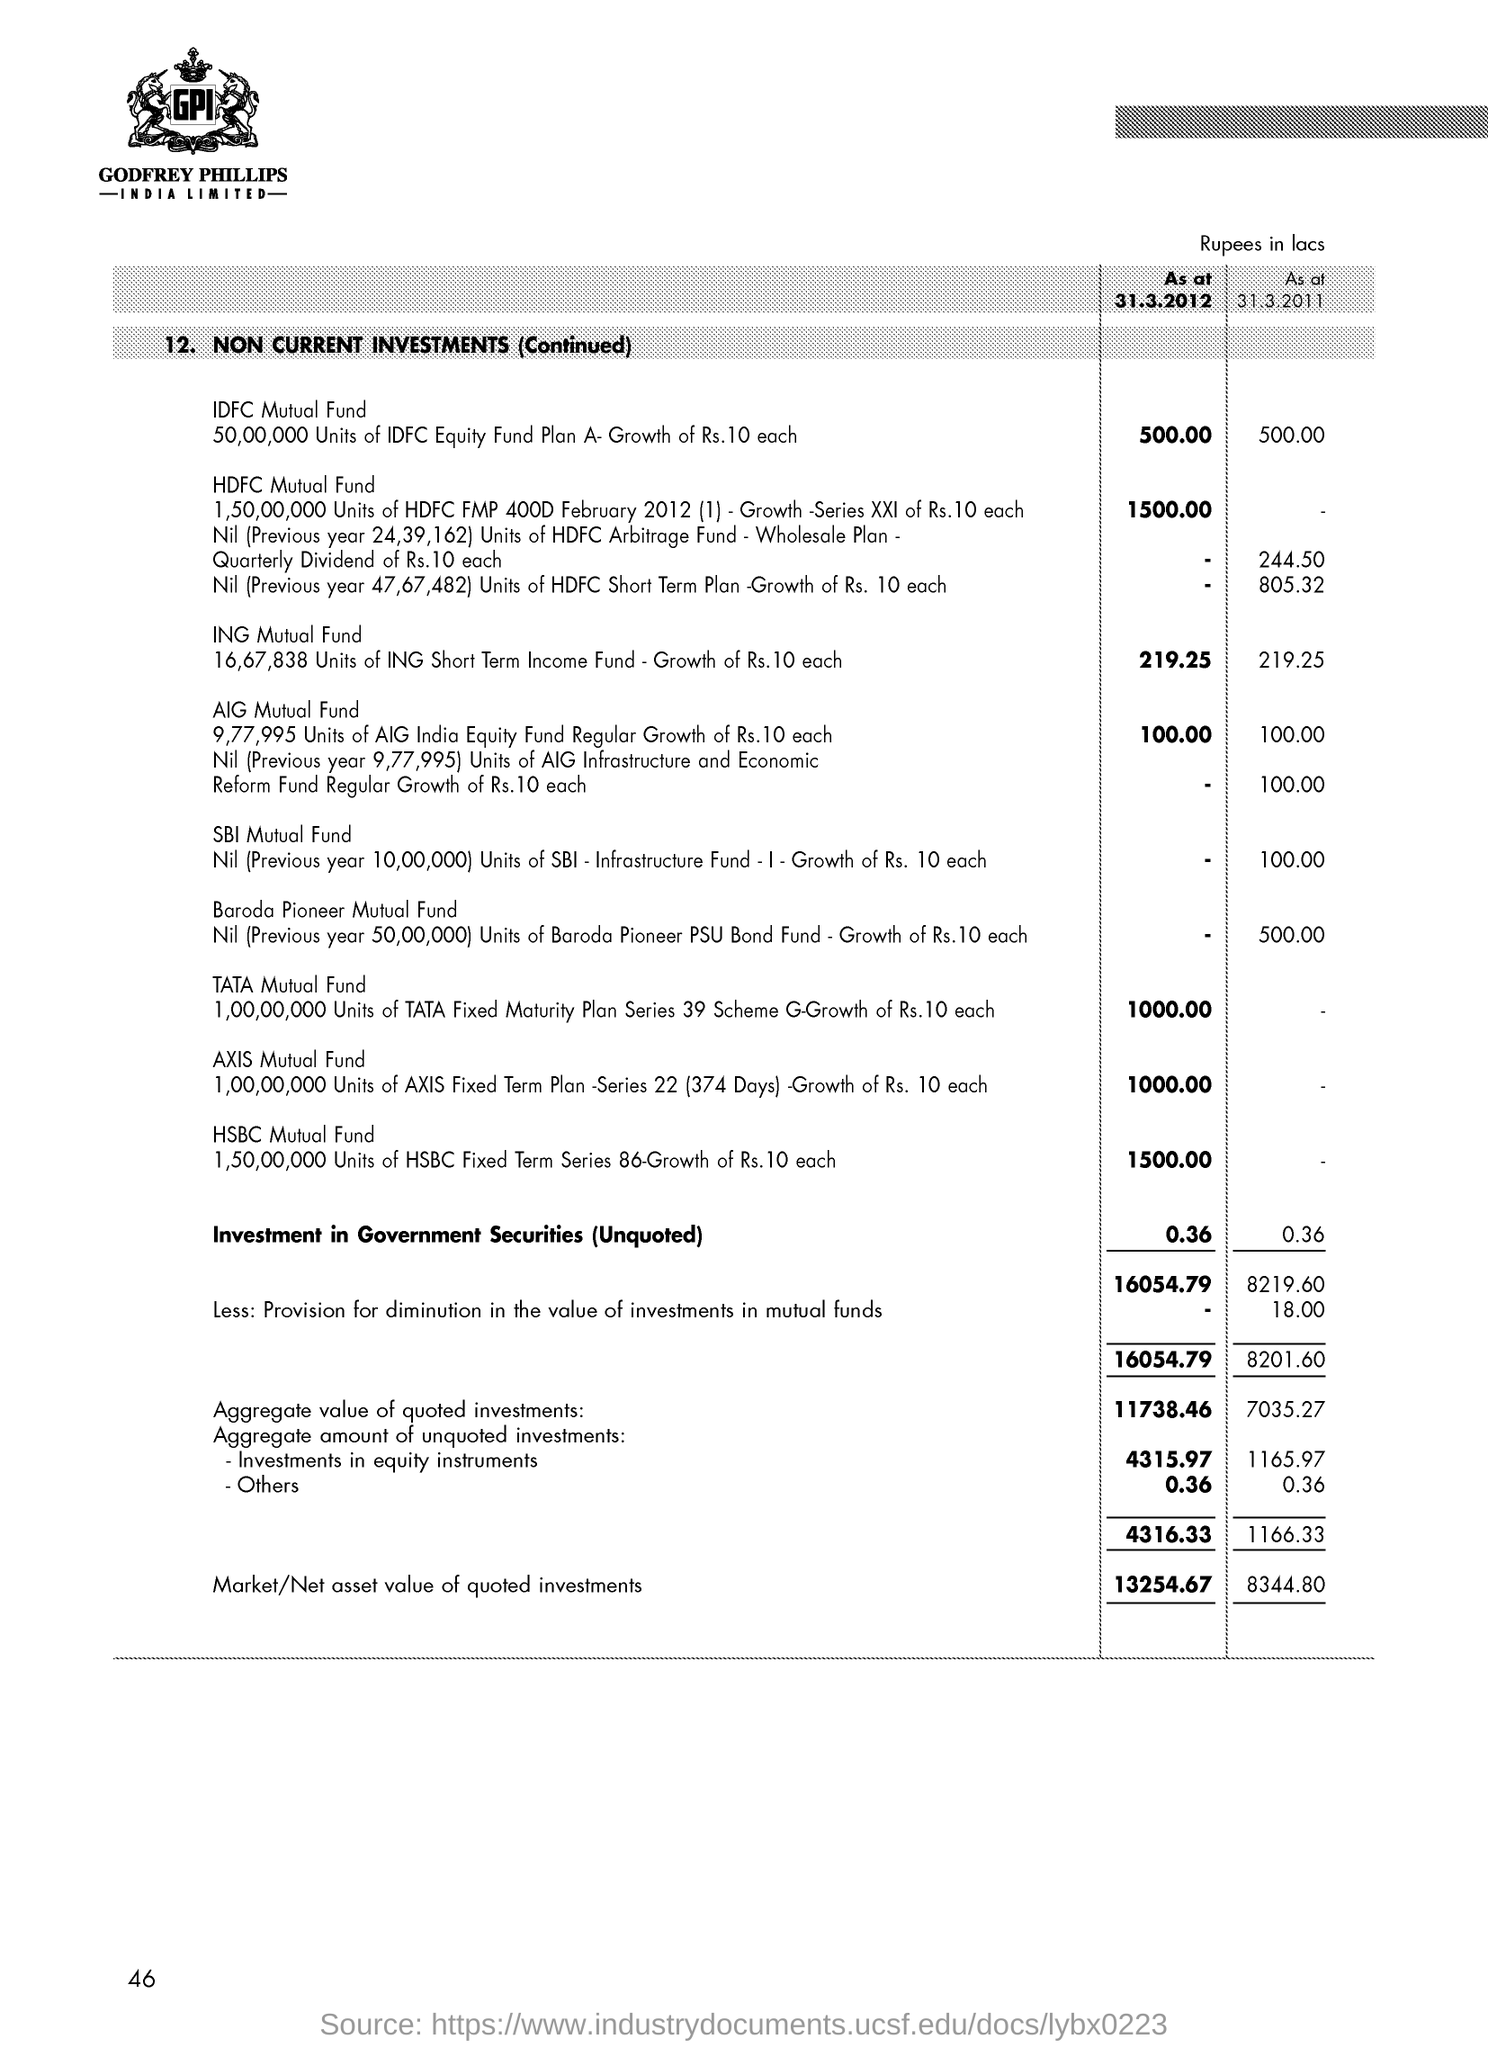How much is the idfc mutual fund as at 31.3.2012?
Your answer should be compact. 500.00. How much is the total market/net asset value of quoted investments as on 31.3.2012?
Offer a very short reply. 13254.67. How much is the investment in government securities (unquoted) as at 31.3.2012?
Keep it short and to the point. 0.36. How much is the hsbc mutual fund as at 31.3.2012?
Offer a very short reply. 1500.00. 